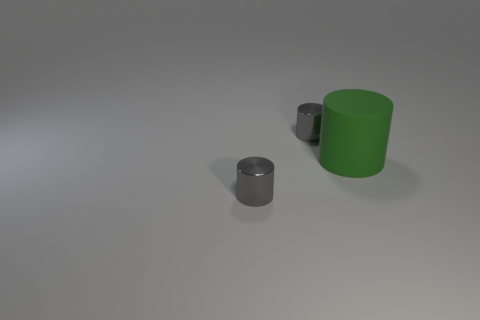Subtract all small metallic cylinders. How many cylinders are left? 1 Subtract all brown cubes. How many gray cylinders are left? 2 Subtract 1 cylinders. How many cylinders are left? 2 Add 3 purple metallic objects. How many objects exist? 6 Add 1 small metal objects. How many small metal objects are left? 3 Add 3 tiny gray metal things. How many tiny gray metal things exist? 5 Subtract 0 yellow cylinders. How many objects are left? 3 Subtract all metal things. Subtract all large green cylinders. How many objects are left? 0 